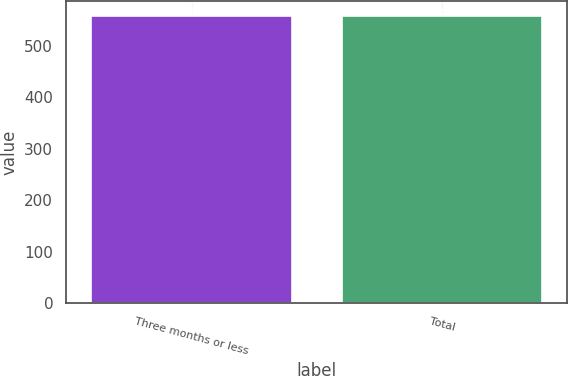Convert chart. <chart><loc_0><loc_0><loc_500><loc_500><bar_chart><fcel>Three months or less<fcel>Total<nl><fcel>558<fcel>558.1<nl></chart> 